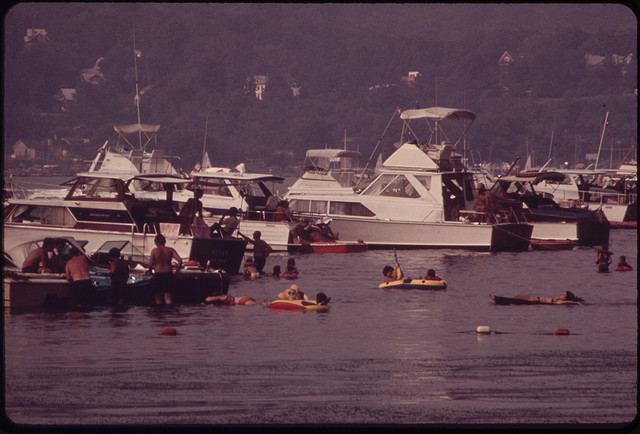<image>What name is written on the fishing boat? The name on the fishing boat is not visible. What color is the sky? I don't know the exact color of the sky. It can be gray, blue or even purple. What name is written on the fishing boat? There is no name visible on the fishing boat. What color is the sky? I don't know what color the sky is. It seems to be gray, but it can also be blue or purple. 